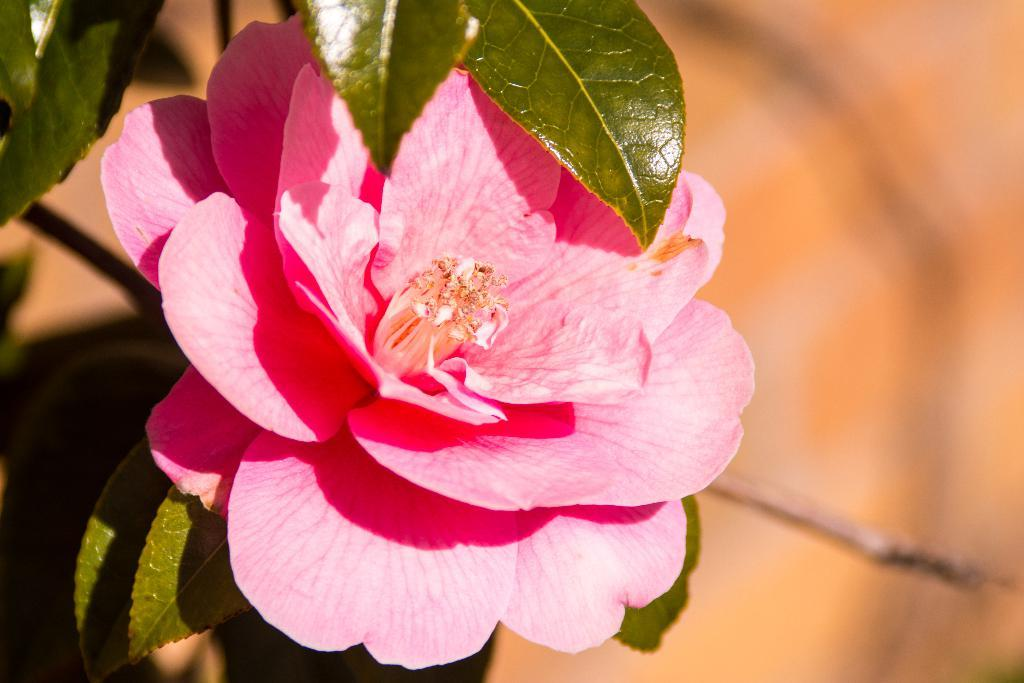What is located in the foreground of the image? There is a flower and leaves in the foreground of the image. Can you describe the background of the image? The background of the image appears blurry. Is there a harbor visible in the background of the image? There is no harbor present in the image; the background appears blurry with no specific features mentioned. 